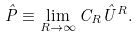Convert formula to latex. <formula><loc_0><loc_0><loc_500><loc_500>\hat { P } \equiv \lim _ { R \to \infty } C _ { R } \hat { U } ^ { R } .</formula> 